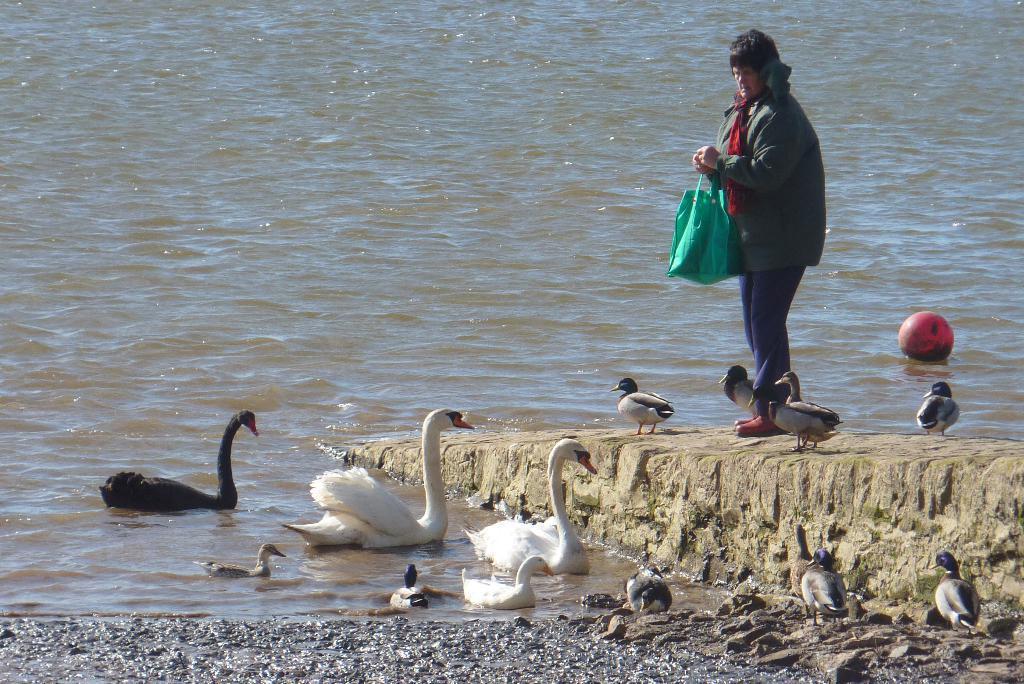Can you describe this image briefly? In this picture there is a woman standing and holding the bag. At the bottom there is a ball and there are swans on the water and there are ducks on the floor and on the ground. 